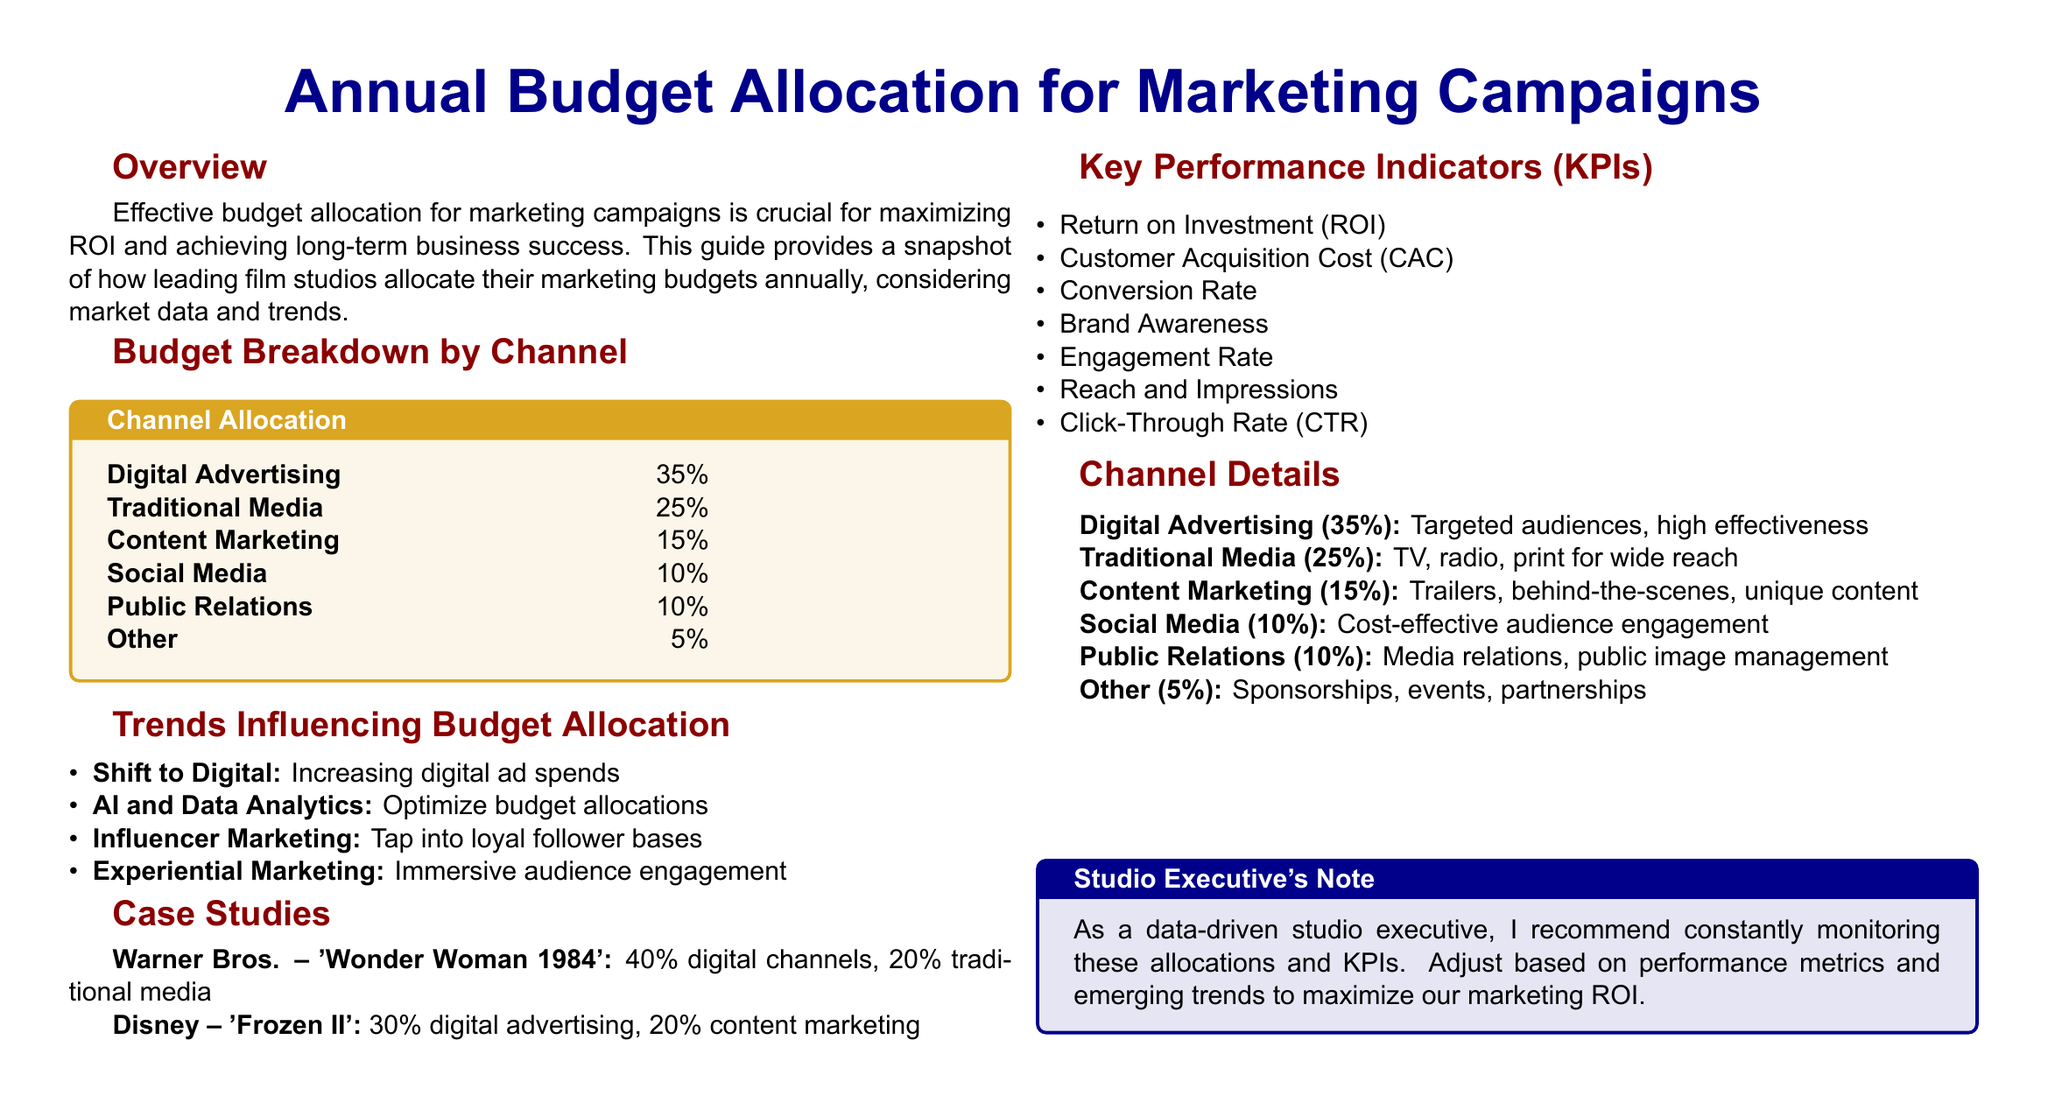What percentage of the budget is allocated to digital advertising? The document states that 35% of the budget is allocated to digital advertising.
Answer: 35% What is the main trend influencing budget allocation? The document lists multiple trends, but "Shift to Digital" is explicitly mentioned as a main trend.
Answer: Shift to Digital Which film by Disney allocated 20% of its budget to content marketing? The document mentions "Frozen II" as the Disney film that allocated 20% to content marketing.
Answer: Frozen II How much of the budget is spent on social media? The document indicates that 10% of the budget is spent on social media.
Answer: 10% What KPI measures the effectiveness of ad spending? Among various KPIs listed, "Return on Investment (ROI)" specifically measures the effectiveness of ad spending.
Answer: Return on Investment Which studio allocated 40% of its budget to digital channels? The document specifies that Warner Bros. allocated 40% to digital channels for 'Wonder Woman 1984'.
Answer: Warner Bros What is the percentage allocation for traditional media? The document outlines that 25% of the budget is allocated to traditional media.
Answer: 25% What type of marketing is characterized by trailers and behind-the-scenes content? The document identifies "Content Marketing" as the type that includes trailers and behind-the-scenes content.
Answer: Content Marketing How many key performance indicators (KPIs) are listed in the document? The document lists seven KPIs in total.
Answer: 7 